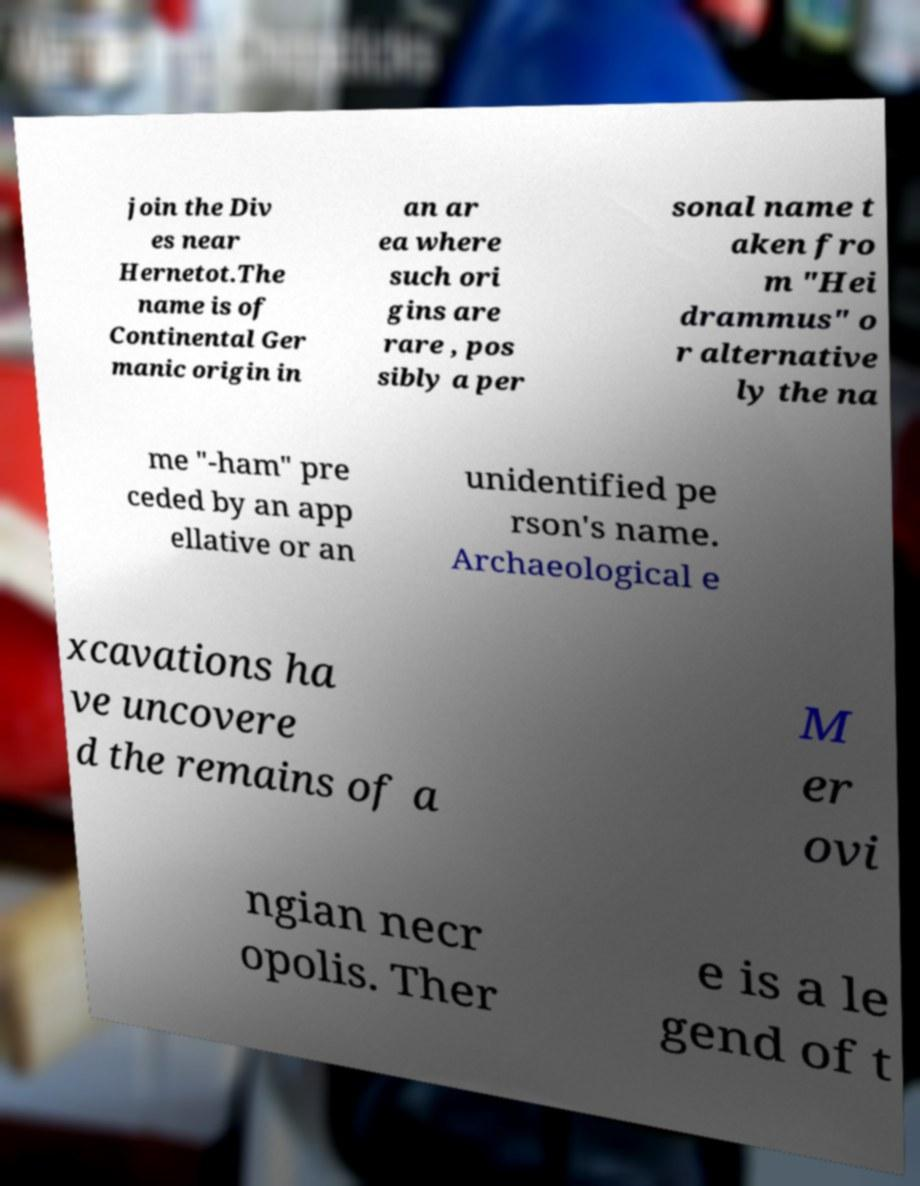Could you extract and type out the text from this image? join the Div es near Hernetot.The name is of Continental Ger manic origin in an ar ea where such ori gins are rare , pos sibly a per sonal name t aken fro m "Hei drammus" o r alternative ly the na me "-ham" pre ceded by an app ellative or an unidentified pe rson's name. Archaeological e xcavations ha ve uncovere d the remains of a M er ovi ngian necr opolis. Ther e is a le gend of t 